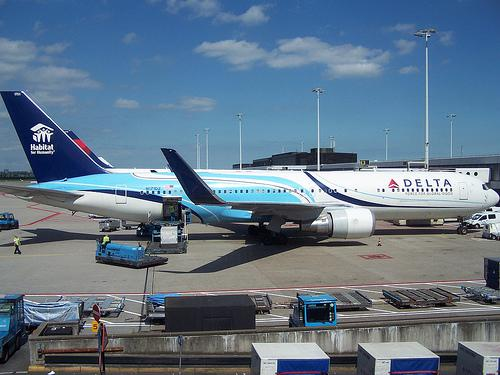Question: when was the picture taken?
Choices:
A. At night.
B. Daytime.
C. In the morning.
D. In the winter.
Answer with the letter. Answer: B Question: what is blue?
Choices:
A. Car.
B. Bus.
C. Umbrella.
D. Sky.
Answer with the letter. Answer: D Question: what is in the sky?
Choices:
A. Kites.
B. Clouds.
C. Plane.
D. The frisbee.
Answer with the letter. Answer: B Question: why does a plane have wings?
Choices:
A. To fly.
B. To hold the engines.
C. To cover fuel lines.
D. To create lift.
Answer with the letter. Answer: A Question: what is white and blue?
Choices:
A. Plane.
B. Sign.
C. Car.
D. Bus.
Answer with the letter. Answer: A Question: where was the photo taken?
Choices:
A. By the pool.
B. At the airport.
C. At the school.
D. In the kitchen.
Answer with the letter. Answer: B 